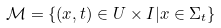Convert formula to latex. <formula><loc_0><loc_0><loc_500><loc_500>\mathcal { M } = \{ ( x , t ) \in U \times I | x \in \Sigma _ { t } \}</formula> 